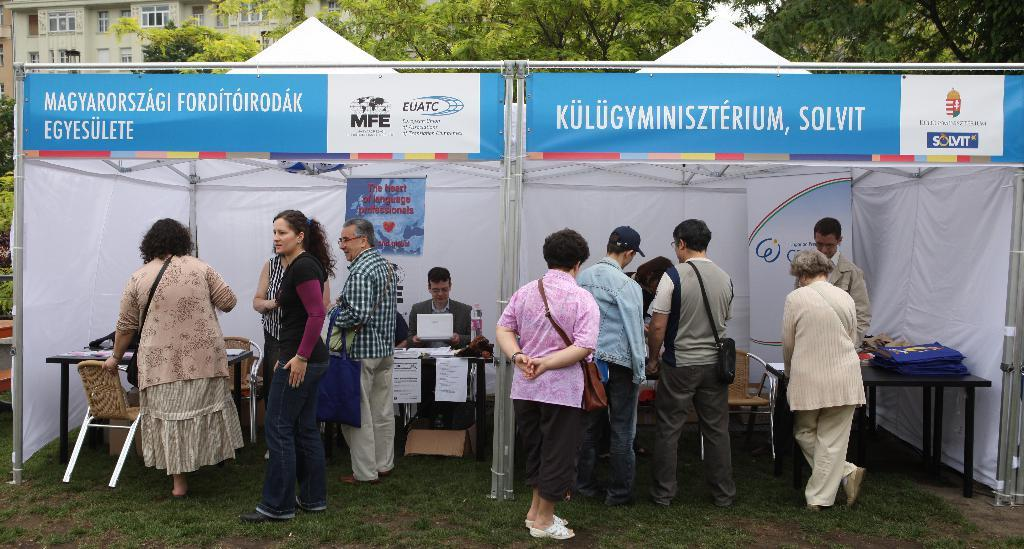What type of vegetation is in the foreground of the image? There is grass in the foreground of the image. What structure can be seen in the image? There is a stall in the image. Who or what is present in the image? There are people in the image. What electronic devices are visible in the image? There are laptops in the image. What type of furniture is in the image? There are chairs and tables in the image. What can be seen in the background of the image? There are trees and buildings in the background of the image. Can you see a hill in the background of the image? There is no hill visible in the background of the image; it features trees and buildings. Is there a branch that someone is kicking in the image? There is no branch or kicking activity present in the image. 